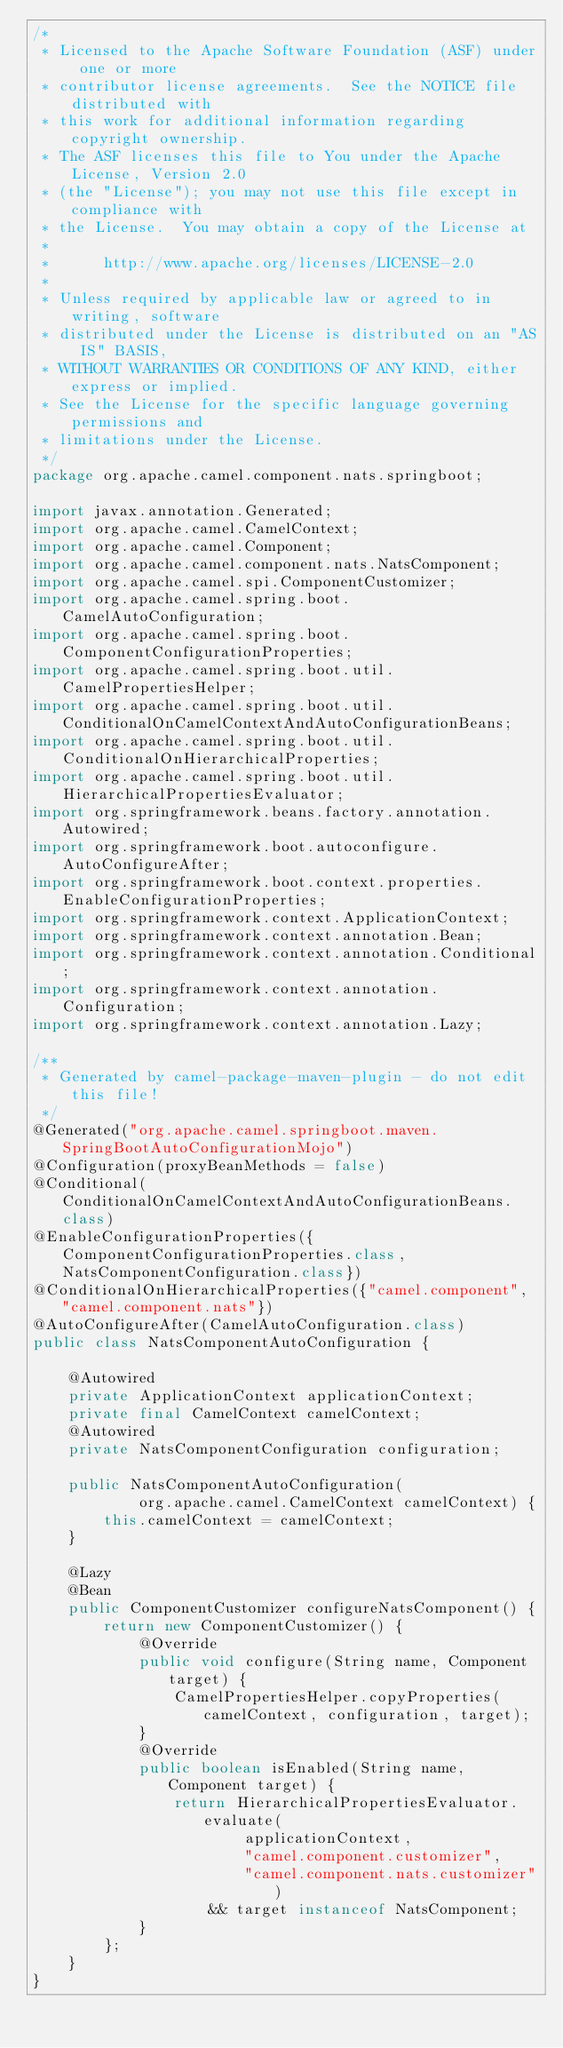Convert code to text. <code><loc_0><loc_0><loc_500><loc_500><_Java_>/*
 * Licensed to the Apache Software Foundation (ASF) under one or more
 * contributor license agreements.  See the NOTICE file distributed with
 * this work for additional information regarding copyright ownership.
 * The ASF licenses this file to You under the Apache License, Version 2.0
 * (the "License"); you may not use this file except in compliance with
 * the License.  You may obtain a copy of the License at
 *
 *      http://www.apache.org/licenses/LICENSE-2.0
 *
 * Unless required by applicable law or agreed to in writing, software
 * distributed under the License is distributed on an "AS IS" BASIS,
 * WITHOUT WARRANTIES OR CONDITIONS OF ANY KIND, either express or implied.
 * See the License for the specific language governing permissions and
 * limitations under the License.
 */
package org.apache.camel.component.nats.springboot;

import javax.annotation.Generated;
import org.apache.camel.CamelContext;
import org.apache.camel.Component;
import org.apache.camel.component.nats.NatsComponent;
import org.apache.camel.spi.ComponentCustomizer;
import org.apache.camel.spring.boot.CamelAutoConfiguration;
import org.apache.camel.spring.boot.ComponentConfigurationProperties;
import org.apache.camel.spring.boot.util.CamelPropertiesHelper;
import org.apache.camel.spring.boot.util.ConditionalOnCamelContextAndAutoConfigurationBeans;
import org.apache.camel.spring.boot.util.ConditionalOnHierarchicalProperties;
import org.apache.camel.spring.boot.util.HierarchicalPropertiesEvaluator;
import org.springframework.beans.factory.annotation.Autowired;
import org.springframework.boot.autoconfigure.AutoConfigureAfter;
import org.springframework.boot.context.properties.EnableConfigurationProperties;
import org.springframework.context.ApplicationContext;
import org.springframework.context.annotation.Bean;
import org.springframework.context.annotation.Conditional;
import org.springframework.context.annotation.Configuration;
import org.springframework.context.annotation.Lazy;

/**
 * Generated by camel-package-maven-plugin - do not edit this file!
 */
@Generated("org.apache.camel.springboot.maven.SpringBootAutoConfigurationMojo")
@Configuration(proxyBeanMethods = false)
@Conditional(ConditionalOnCamelContextAndAutoConfigurationBeans.class)
@EnableConfigurationProperties({ComponentConfigurationProperties.class,NatsComponentConfiguration.class})
@ConditionalOnHierarchicalProperties({"camel.component", "camel.component.nats"})
@AutoConfigureAfter(CamelAutoConfiguration.class)
public class NatsComponentAutoConfiguration {

    @Autowired
    private ApplicationContext applicationContext;
    private final CamelContext camelContext;
    @Autowired
    private NatsComponentConfiguration configuration;

    public NatsComponentAutoConfiguration(
            org.apache.camel.CamelContext camelContext) {
        this.camelContext = camelContext;
    }

    @Lazy
    @Bean
    public ComponentCustomizer configureNatsComponent() {
        return new ComponentCustomizer() {
            @Override
            public void configure(String name, Component target) {
                CamelPropertiesHelper.copyProperties(camelContext, configuration, target);
            }
            @Override
            public boolean isEnabled(String name, Component target) {
                return HierarchicalPropertiesEvaluator.evaluate(
                        applicationContext,
                        "camel.component.customizer",
                        "camel.component.nats.customizer")
                    && target instanceof NatsComponent;
            }
        };
    }
}</code> 